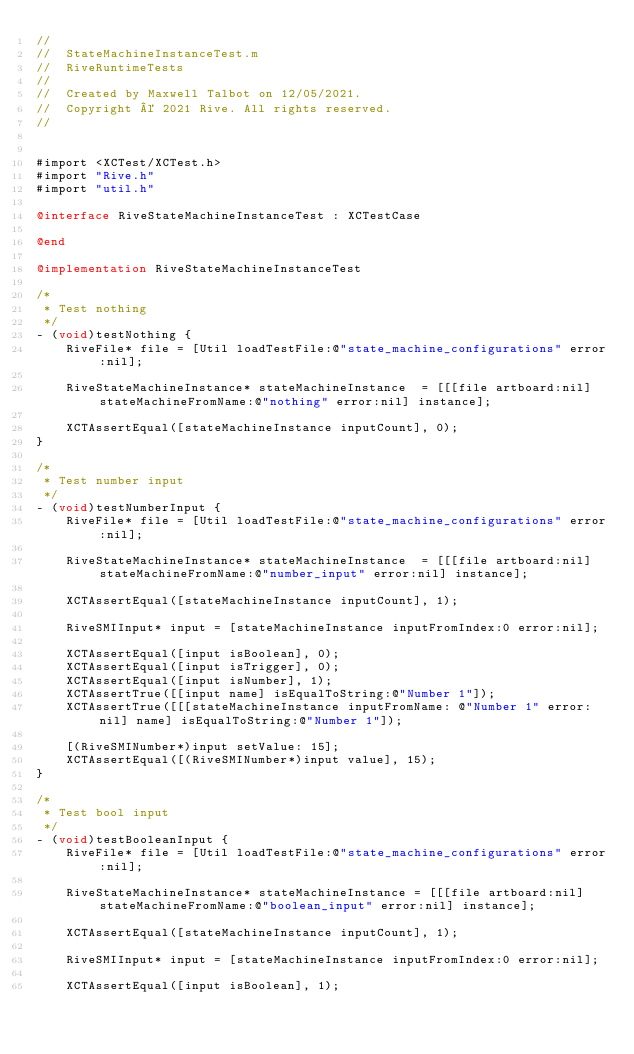Convert code to text. <code><loc_0><loc_0><loc_500><loc_500><_ObjectiveC_>//
//  StateMachineInstanceTest.m
//  RiveRuntimeTests
//
//  Created by Maxwell Talbot on 12/05/2021.
//  Copyright © 2021 Rive. All rights reserved.
//


#import <XCTest/XCTest.h>
#import "Rive.h"
#import "util.h"

@interface RiveStateMachineInstanceTest : XCTestCase

@end

@implementation RiveStateMachineInstanceTest

/*
 * Test nothing
 */
- (void)testNothing {
    RiveFile* file = [Util loadTestFile:@"state_machine_configurations" error:nil];
    
    RiveStateMachineInstance* stateMachineInstance  = [[[file artboard:nil] stateMachineFromName:@"nothing" error:nil] instance];

    XCTAssertEqual([stateMachineInstance inputCount], 0);
}

/*
 * Test number input
 */
- (void)testNumberInput {
    RiveFile* file = [Util loadTestFile:@"state_machine_configurations" error:nil];
    
    RiveStateMachineInstance* stateMachineInstance  = [[[file artboard:nil] stateMachineFromName:@"number_input" error:nil] instance];

    XCTAssertEqual([stateMachineInstance inputCount], 1);
    
    RiveSMIInput* input = [stateMachineInstance inputFromIndex:0 error:nil];
    
    XCTAssertEqual([input isBoolean], 0);
    XCTAssertEqual([input isTrigger], 0);
    XCTAssertEqual([input isNumber], 1);
    XCTAssertTrue([[input name] isEqualToString:@"Number 1"]);
    XCTAssertTrue([[[stateMachineInstance inputFromName: @"Number 1" error:nil] name] isEqualToString:@"Number 1"]);
    
    [(RiveSMINumber*)input setValue: 15];
    XCTAssertEqual([(RiveSMINumber*)input value], 15);
}

/*
 * Test bool input
 */
- (void)testBooleanInput {
    RiveFile* file = [Util loadTestFile:@"state_machine_configurations" error:nil];
    
    RiveStateMachineInstance* stateMachineInstance = [[[file artboard:nil] stateMachineFromName:@"boolean_input" error:nil] instance];

    XCTAssertEqual([stateMachineInstance inputCount], 1);
    
    RiveSMIInput* input = [stateMachineInstance inputFromIndex:0 error:nil];
    
    XCTAssertEqual([input isBoolean], 1);</code> 